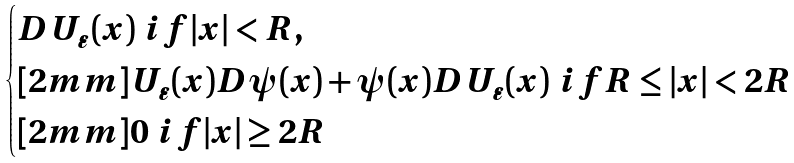<formula> <loc_0><loc_0><loc_500><loc_500>\begin{cases} D U _ { \varepsilon } ( x ) \ i f | x | < R , \\ [ 2 m m ] U _ { \varepsilon } ( x ) D \psi ( x ) + \psi ( x ) D U _ { \varepsilon } ( x ) \ i f R \leq | x | < 2 R \\ [ 2 m m ] 0 \ i f | x | \geq 2 R \end{cases}</formula> 